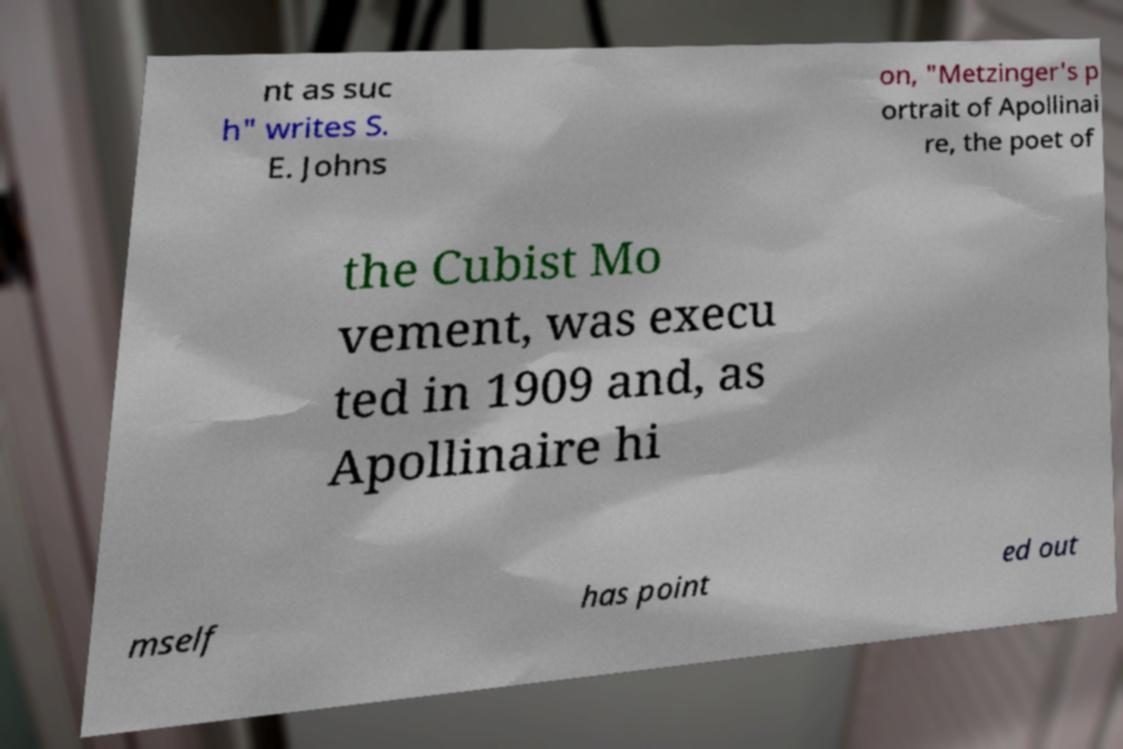Please read and relay the text visible in this image. What does it say? nt as suc h" writes S. E. Johns on, "Metzinger's p ortrait of Apollinai re, the poet of the Cubist Mo vement, was execu ted in 1909 and, as Apollinaire hi mself has point ed out 